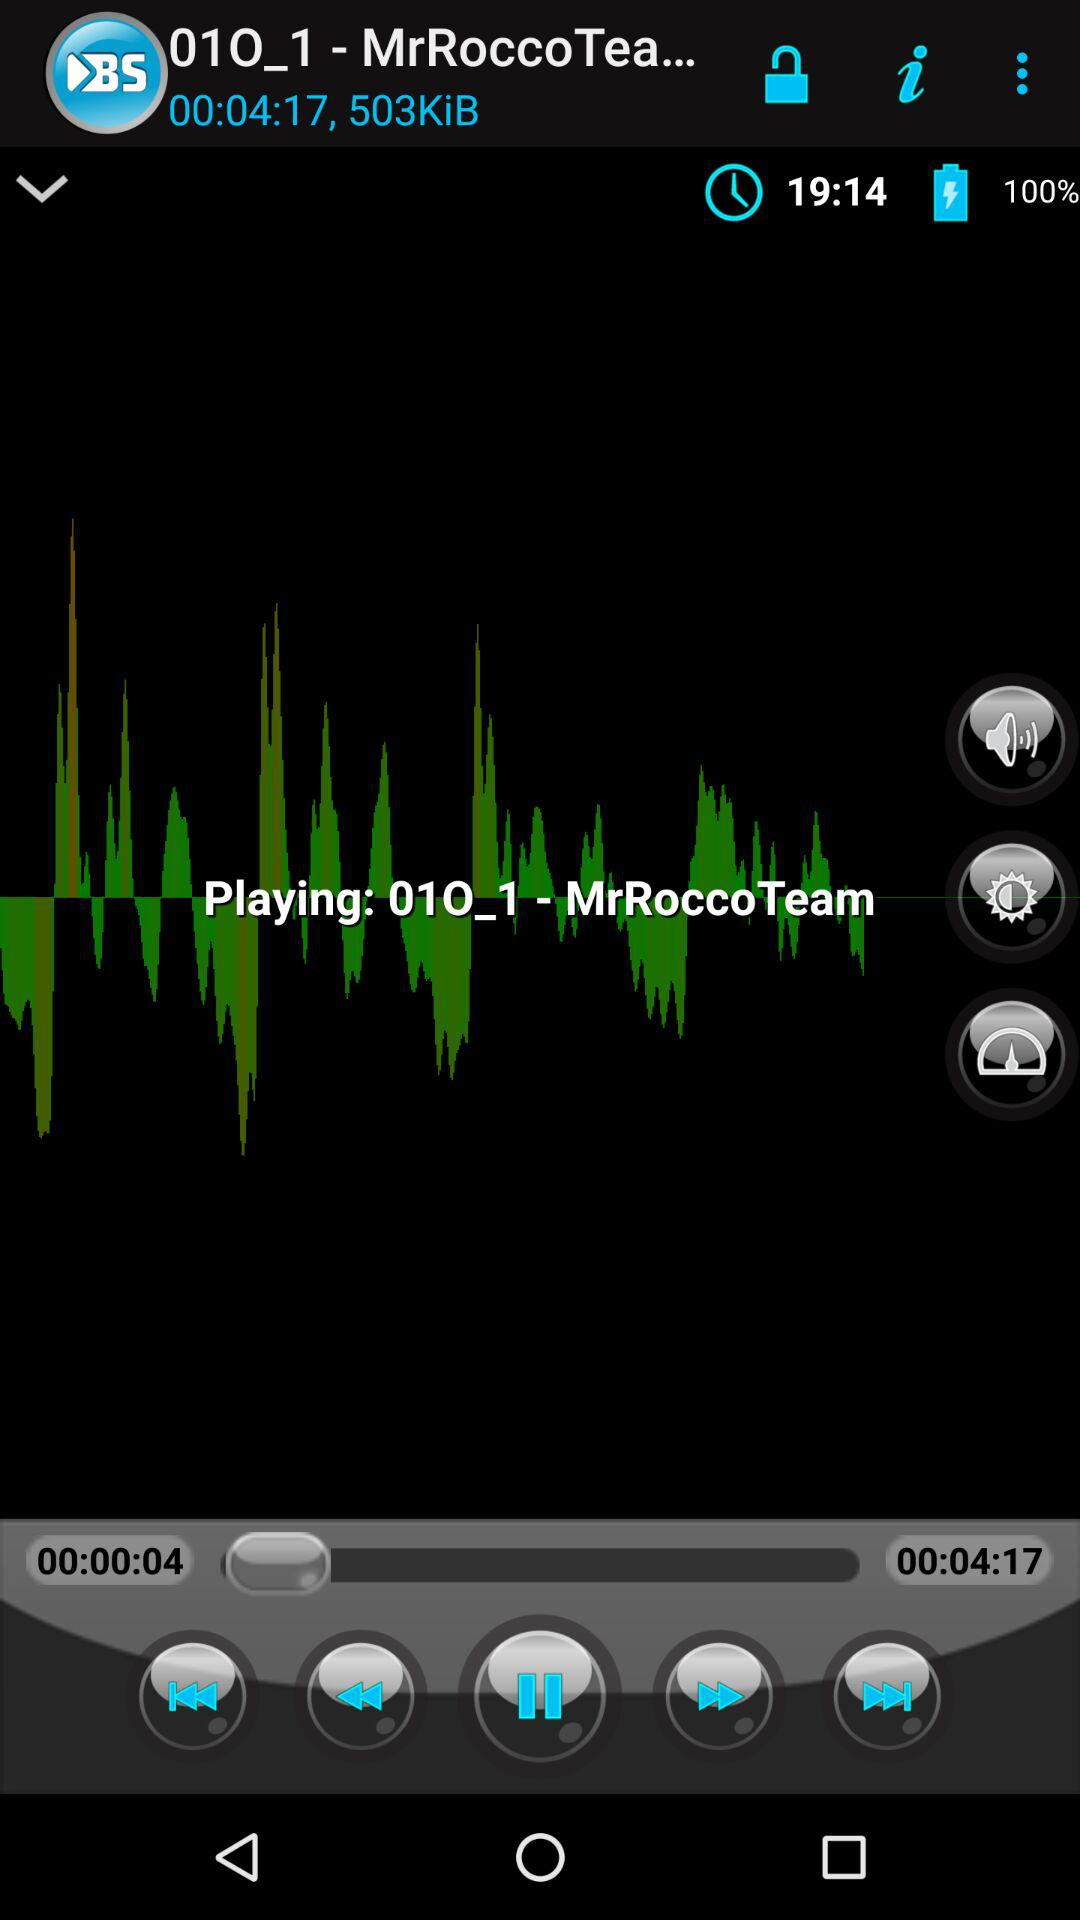How loud is the volume?
When the provided information is insufficient, respond with <no answer>. <no answer> 